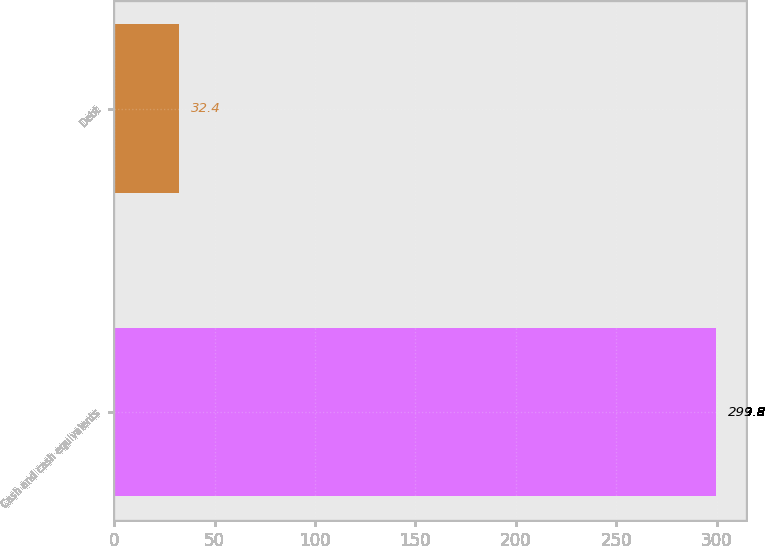<chart> <loc_0><loc_0><loc_500><loc_500><bar_chart><fcel>Cash and cash equivalents<fcel>Debt<nl><fcel>299.8<fcel>32.4<nl></chart> 